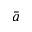<formula> <loc_0><loc_0><loc_500><loc_500>\bar { a }</formula> 